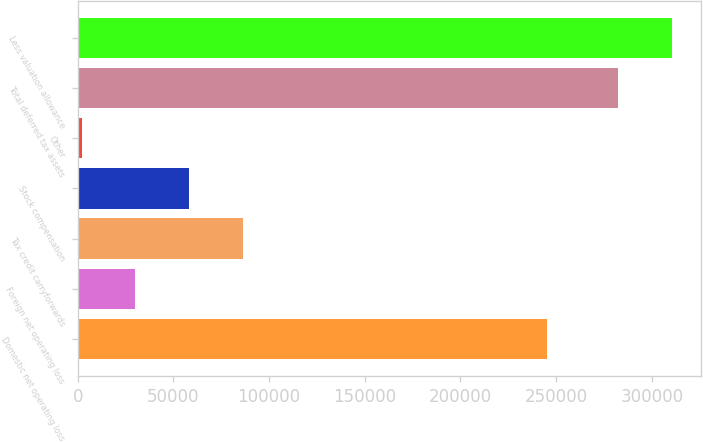<chart> <loc_0><loc_0><loc_500><loc_500><bar_chart><fcel>Domestic net operating loss<fcel>Foreign net operating loss<fcel>Tax credit carryforwards<fcel>Stock compensation<fcel>Other<fcel>Total deferred tax assets<fcel>Less valuation allowance<nl><fcel>245454<fcel>30134.8<fcel>86196.4<fcel>58165.6<fcel>2104<fcel>282412<fcel>310443<nl></chart> 